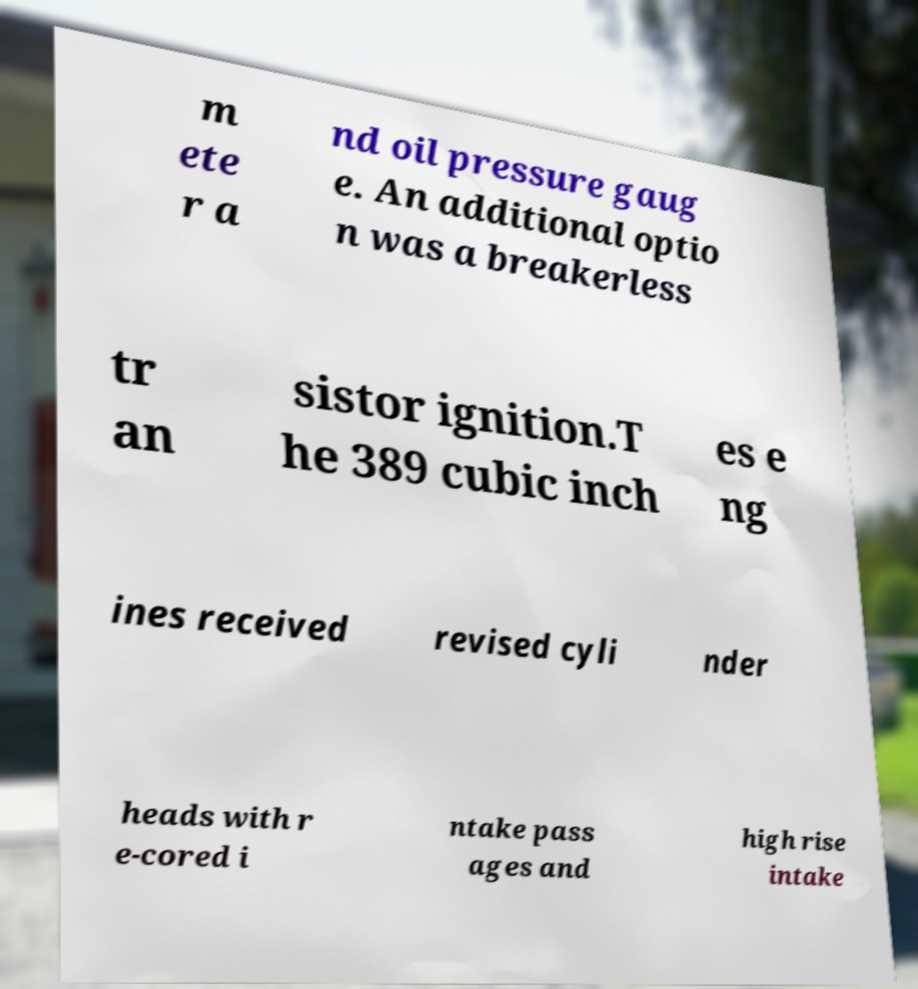Can you read and provide the text displayed in the image?This photo seems to have some interesting text. Can you extract and type it out for me? m ete r a nd oil pressure gaug e. An additional optio n was a breakerless tr an sistor ignition.T he 389 cubic inch es e ng ines received revised cyli nder heads with r e-cored i ntake pass ages and high rise intake 